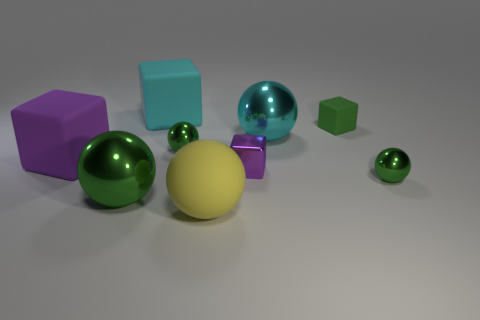Subtract all yellow cubes. How many green balls are left? 3 Subtract 1 blocks. How many blocks are left? 3 Subtract all big yellow rubber balls. How many balls are left? 4 Subtract all red spheres. Subtract all gray cylinders. How many spheres are left? 5 Add 1 cyan metal things. How many objects exist? 10 Subtract all blocks. How many objects are left? 5 Add 3 tiny blocks. How many tiny blocks exist? 5 Subtract 0 red balls. How many objects are left? 9 Subtract all small cyan metallic blocks. Subtract all yellow objects. How many objects are left? 8 Add 4 big matte cubes. How many big matte cubes are left? 6 